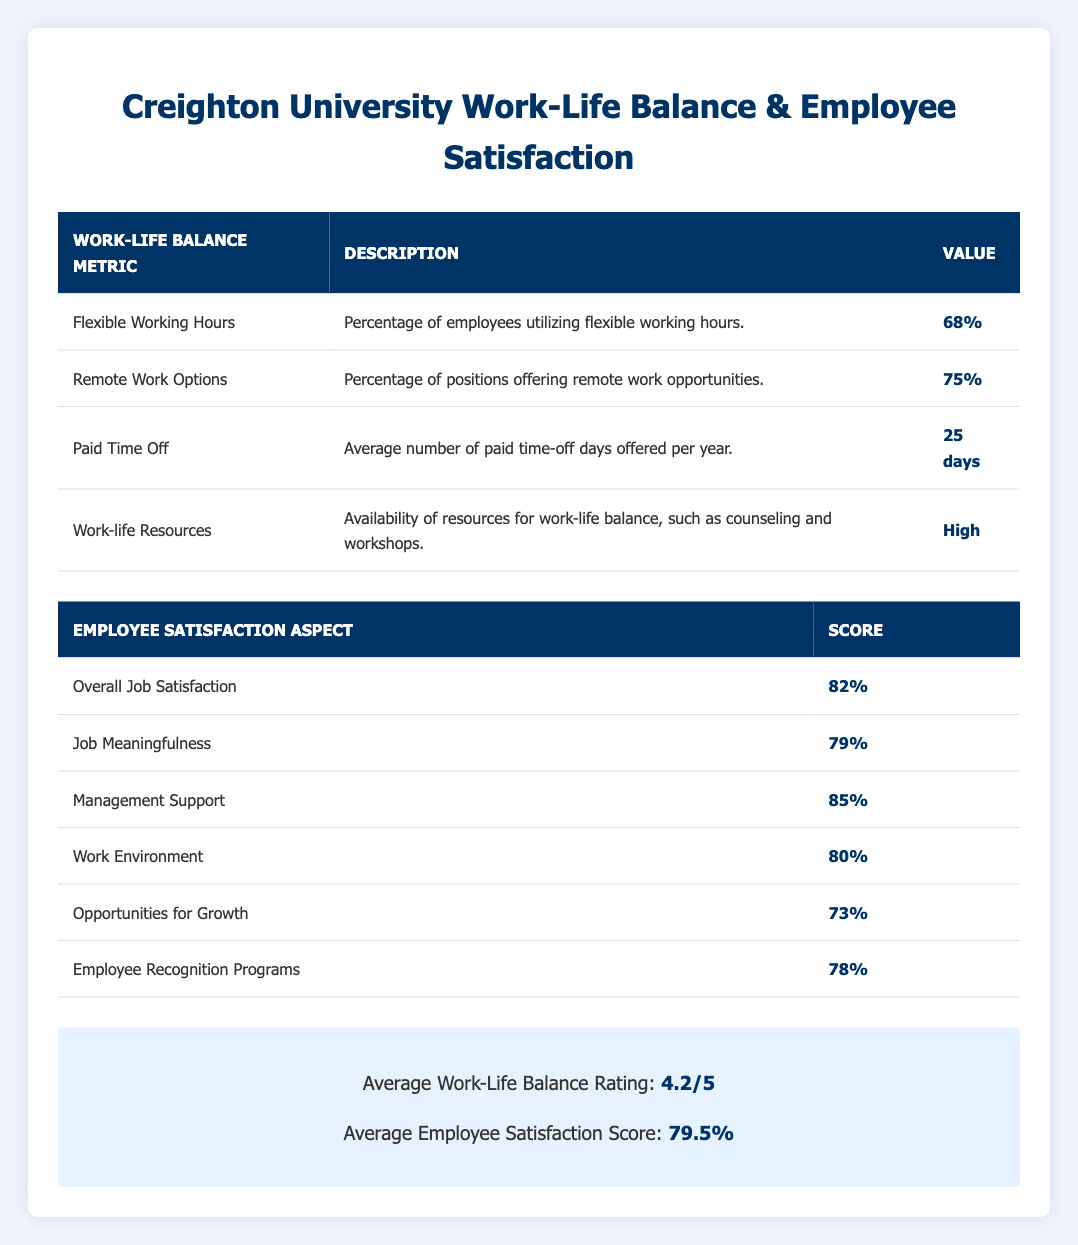What percentage of employees utilize flexible working hours? The table shows that the metric for flexible working hours has a value of 68%.
Answer: 68% What is the average number of paid time-off days offered per year at Creighton University? The table specifies that the average number of paid time-off days offered is 25 days.
Answer: 25 days Is the score for management support greater than 80%? The score for management support is 85%, which is indeed greater than 80%.
Answer: Yes What is the average employee satisfaction score? The summary section of the table indicates that the average employee satisfaction score is 79.5%.
Answer: 79.5% How many employees utilize remote work options? The table notes that 75% of positions offer remote work opportunities, indicating a potential high utilization among employees.
Answer: 75% What is the difference between the scores for overall job satisfaction and opportunities for growth? The overall job satisfaction score is 82%, and the opportunities for growth score is 73%. The difference is 82% - 73% = 9%.
Answer: 9% What is the highest score among the employee satisfaction aspects listed? The scores listed for employee satisfaction aspects show that management support has the highest score at 85%.
Answer: 85% What percentage of employees rated the work environment at Creighton University? The work environment score is 80%, as stated in the employee satisfaction survey results.
Answer: 80% Is the score for job meaningfulness below 75%? The score for job meaningfulness is 79%, which is above 75%.
Answer: No What is the average score of the employee recognition programs and job meaningfulness? The score for employee recognition programs is 78%, and for job meaningfulness, it is 79%. The average score is (78% + 79%) / 2 = 78.5%.
Answer: 78.5% 